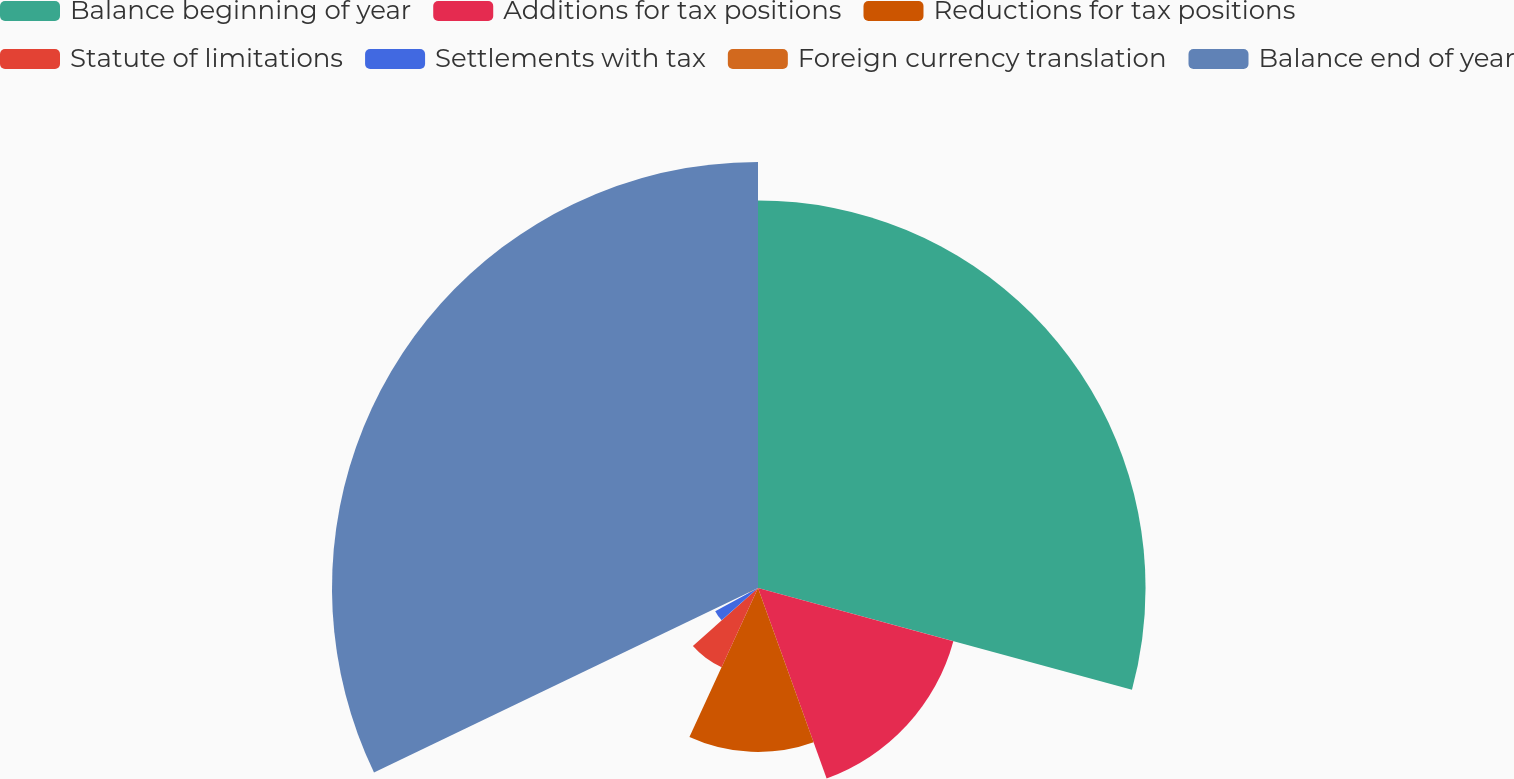<chart> <loc_0><loc_0><loc_500><loc_500><pie_chart><fcel>Balance beginning of year<fcel>Additions for tax positions<fcel>Reductions for tax positions<fcel>Statute of limitations<fcel>Settlements with tax<fcel>Foreign currency translation<fcel>Balance end of year<nl><fcel>29.23%<fcel>15.27%<fcel>12.37%<fcel>6.57%<fcel>3.67%<fcel>0.77%<fcel>32.13%<nl></chart> 